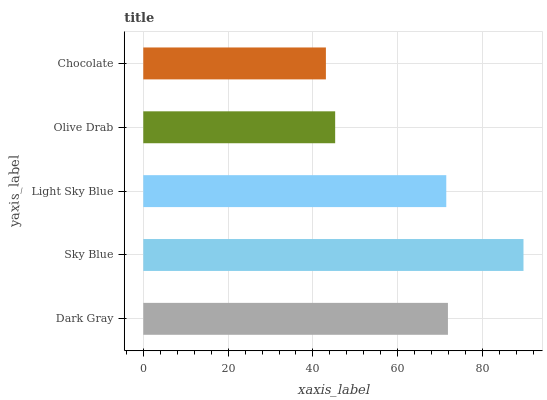Is Chocolate the minimum?
Answer yes or no. Yes. Is Sky Blue the maximum?
Answer yes or no. Yes. Is Light Sky Blue the minimum?
Answer yes or no. No. Is Light Sky Blue the maximum?
Answer yes or no. No. Is Sky Blue greater than Light Sky Blue?
Answer yes or no. Yes. Is Light Sky Blue less than Sky Blue?
Answer yes or no. Yes. Is Light Sky Blue greater than Sky Blue?
Answer yes or no. No. Is Sky Blue less than Light Sky Blue?
Answer yes or no. No. Is Light Sky Blue the high median?
Answer yes or no. Yes. Is Light Sky Blue the low median?
Answer yes or no. Yes. Is Dark Gray the high median?
Answer yes or no. No. Is Olive Drab the low median?
Answer yes or no. No. 